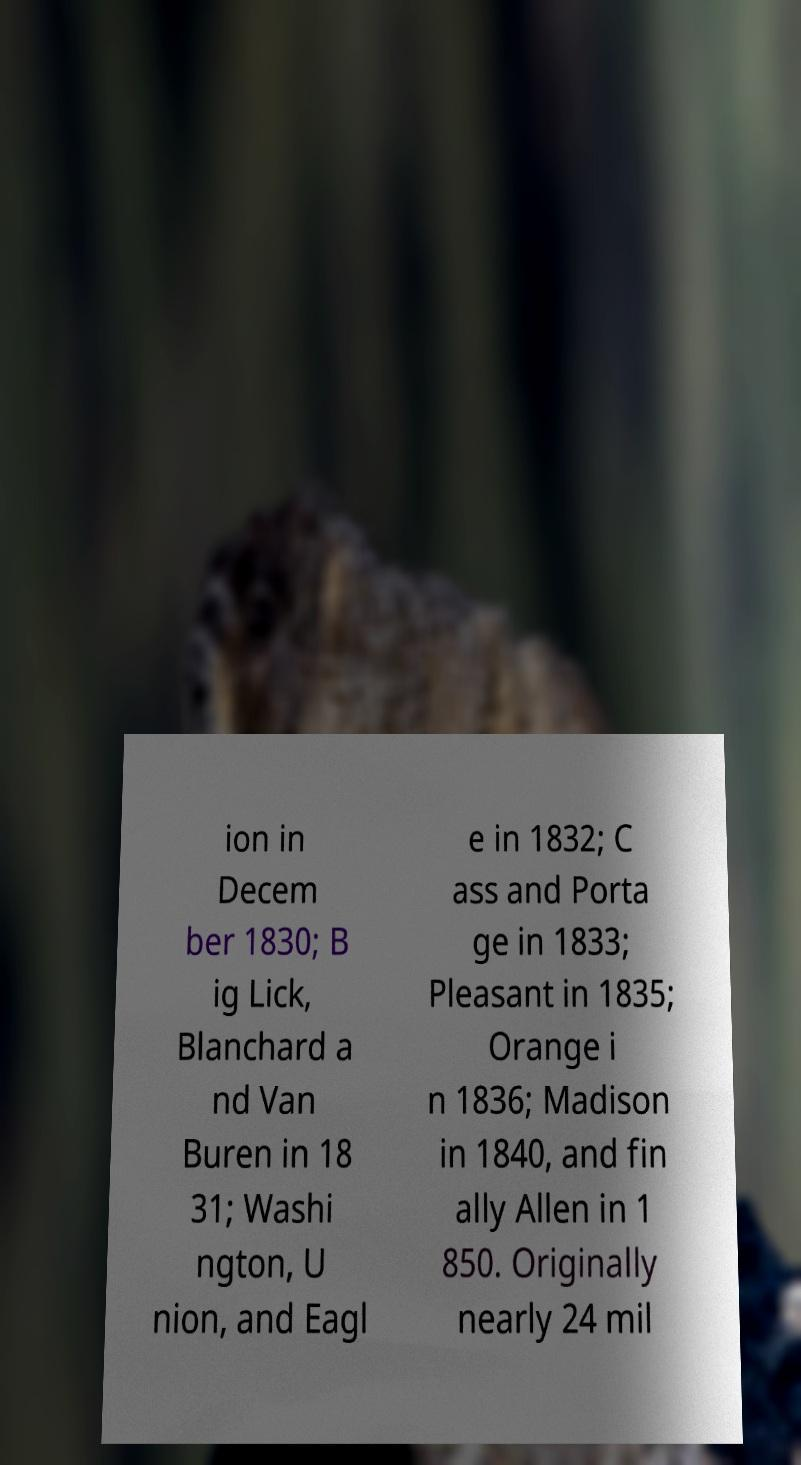What messages or text are displayed in this image? I need them in a readable, typed format. ion in Decem ber 1830; B ig Lick, Blanchard a nd Van Buren in 18 31; Washi ngton, U nion, and Eagl e in 1832; C ass and Porta ge in 1833; Pleasant in 1835; Orange i n 1836; Madison in 1840, and fin ally Allen in 1 850. Originally nearly 24 mil 